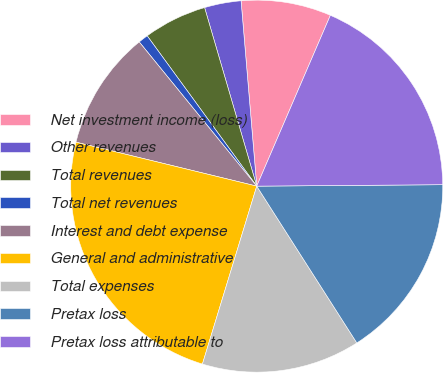<chart> <loc_0><loc_0><loc_500><loc_500><pie_chart><fcel>Net investment income (loss)<fcel>Other revenues<fcel>Total revenues<fcel>Total net revenues<fcel>Interest and debt expense<fcel>General and administrative<fcel>Total expenses<fcel>Pretax loss<fcel>Pretax loss attributable to<nl><fcel>7.82%<fcel>3.18%<fcel>5.5%<fcel>0.86%<fcel>10.32%<fcel>24.08%<fcel>13.76%<fcel>16.08%<fcel>18.4%<nl></chart> 